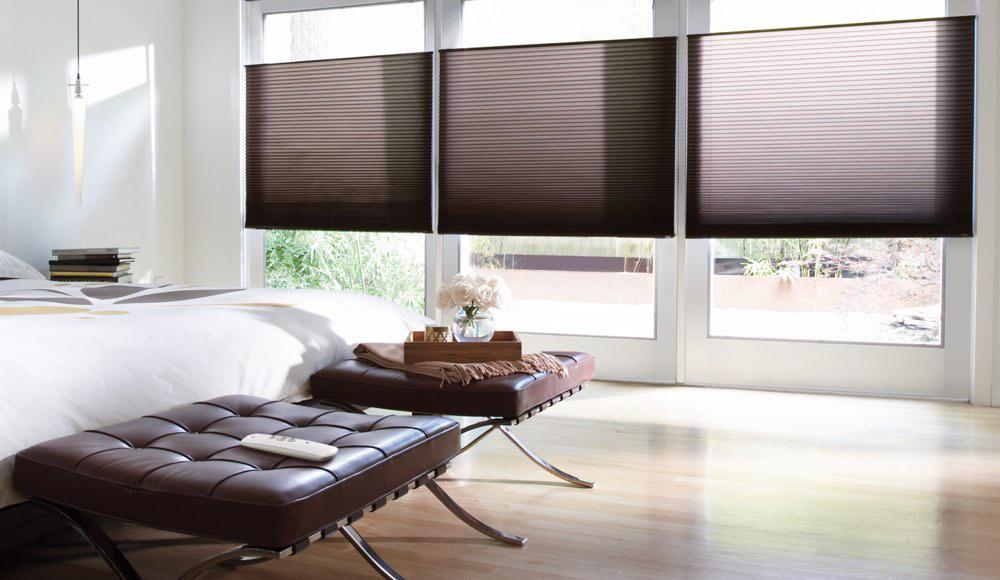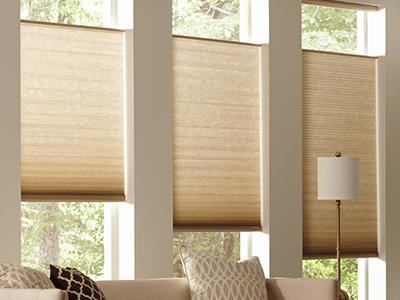The first image is the image on the left, the second image is the image on the right. Analyze the images presented: Is the assertion "The left and right image contains a total of six blinds on the windows." valid? Answer yes or no. Yes. The first image is the image on the left, the second image is the image on the right. Considering the images on both sides, is "At least one couch is sitting in front of the blinds." valid? Answer yes or no. Yes. 